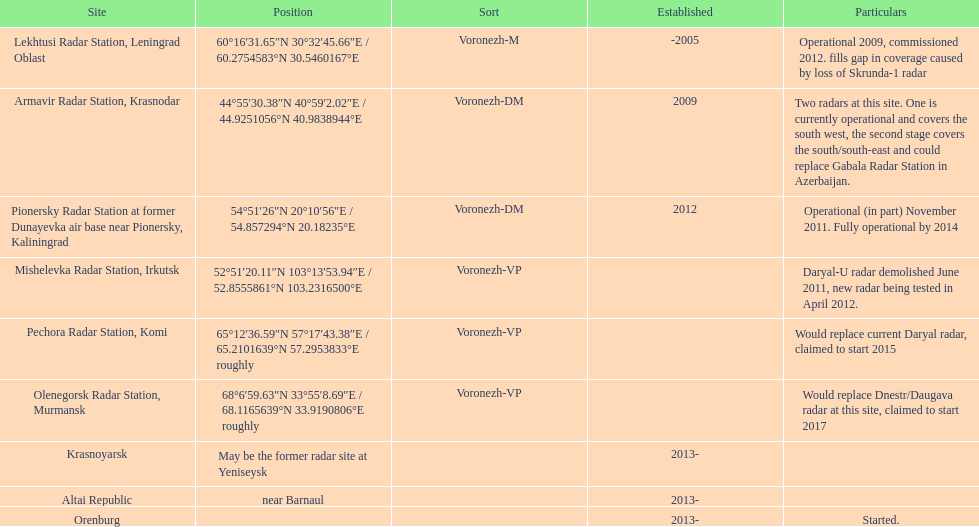Write the full table. {'header': ['Site', 'Position', 'Sort', 'Established', 'Particulars'], 'rows': [['Lekhtusi Radar Station, Leningrad Oblast', '60°16′31.65″N 30°32′45.66″E\ufeff / \ufeff60.2754583°N 30.5460167°E', 'Voronezh-M', '-2005', 'Operational 2009, commissioned 2012. fills gap in coverage caused by loss of Skrunda-1 radar'], ['Armavir Radar Station, Krasnodar', '44°55′30.38″N 40°59′2.02″E\ufeff / \ufeff44.9251056°N 40.9838944°E', 'Voronezh-DM', '2009', 'Two radars at this site. One is currently operational and covers the south west, the second stage covers the south/south-east and could replace Gabala Radar Station in Azerbaijan.'], ['Pionersky Radar Station at former Dunayevka air base near Pionersky, Kaliningrad', '54°51′26″N 20°10′56″E\ufeff / \ufeff54.857294°N 20.18235°E', 'Voronezh-DM', '2012', 'Operational (in part) November 2011. Fully operational by 2014'], ['Mishelevka Radar Station, Irkutsk', '52°51′20.11″N 103°13′53.94″E\ufeff / \ufeff52.8555861°N 103.2316500°E', 'Voronezh-VP', '', 'Daryal-U radar demolished June 2011, new radar being tested in April 2012.'], ['Pechora Radar Station, Komi', '65°12′36.59″N 57°17′43.38″E\ufeff / \ufeff65.2101639°N 57.2953833°E roughly', 'Voronezh-VP', '', 'Would replace current Daryal radar, claimed to start 2015'], ['Olenegorsk Radar Station, Murmansk', '68°6′59.63″N 33°55′8.69″E\ufeff / \ufeff68.1165639°N 33.9190806°E roughly', 'Voronezh-VP', '', 'Would replace Dnestr/Daugava radar at this site, claimed to start 2017'], ['Krasnoyarsk', 'May be the former radar site at Yeniseysk', '', '2013-', ''], ['Altai Republic', 'near Barnaul', '', '2013-', ''], ['Orenburg', '', '', '2013-', 'Started.']]} How many voronezh radars were built before 2010? 2. 